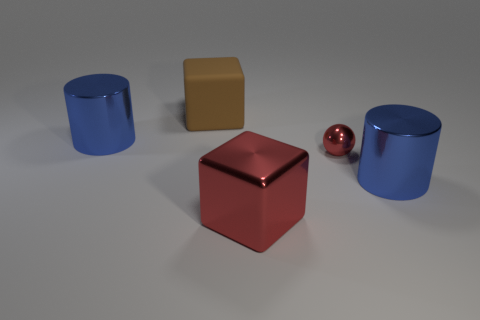Subtract all brown blocks. How many blocks are left? 1 Subtract 1 cylinders. How many cylinders are left? 1 Subtract all spheres. How many objects are left? 4 Add 1 large things. How many objects exist? 6 Subtract all green cylinders. Subtract all purple cubes. How many cylinders are left? 2 Subtract all red spheres. Subtract all brown cubes. How many objects are left? 3 Add 5 big brown rubber blocks. How many big brown rubber blocks are left? 6 Add 4 blue things. How many blue things exist? 6 Subtract 0 cyan cylinders. How many objects are left? 5 